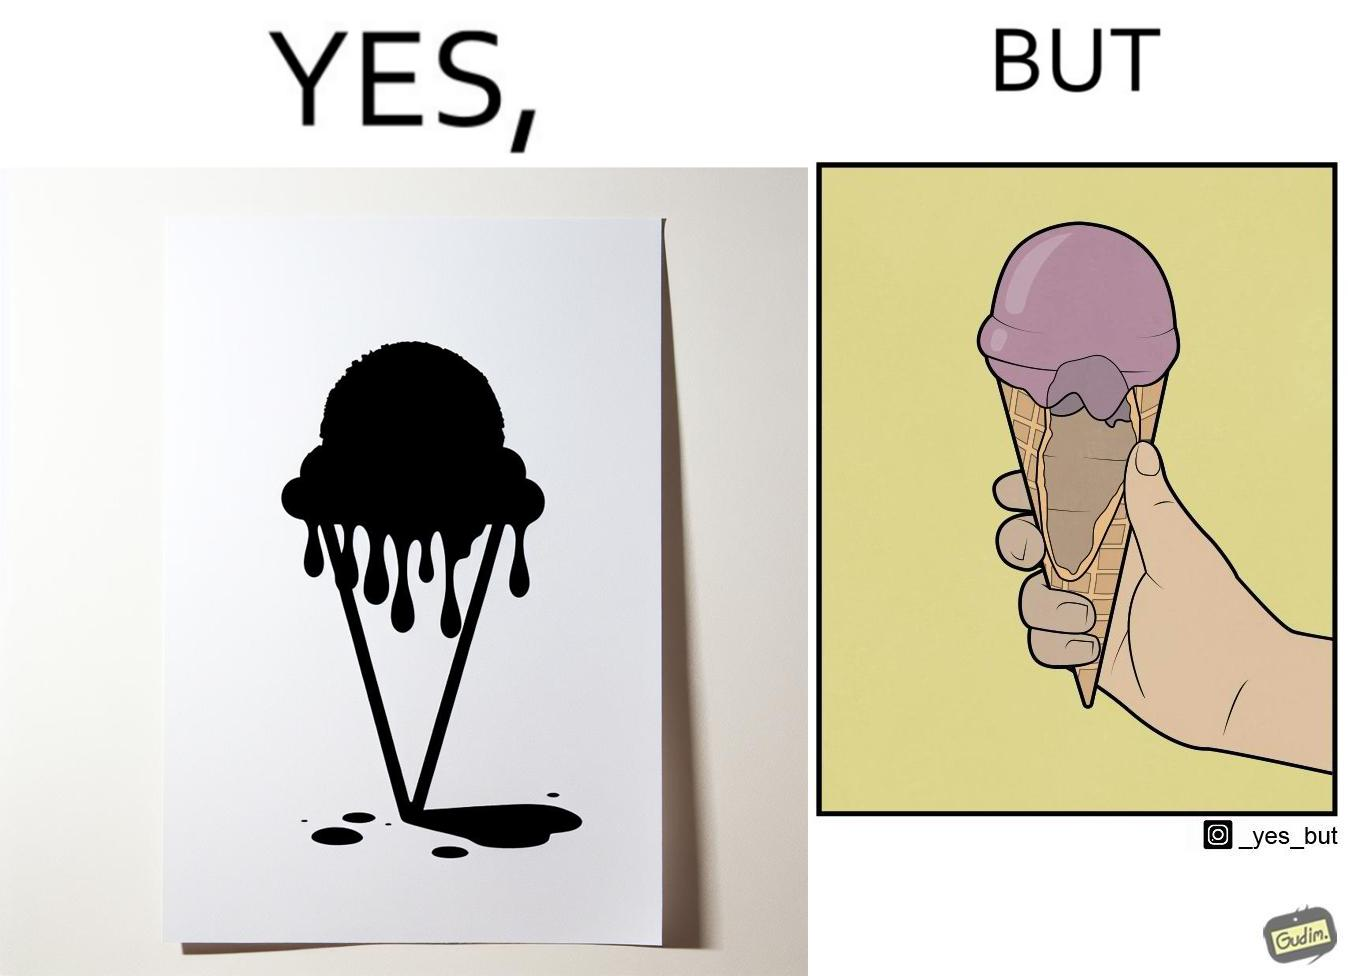What is shown in this image? The image is ironic, because in one image the softy cone is shown filled with softy but in second image it is visible that only the top of the cone is filled and at the inside the cone is vacant 